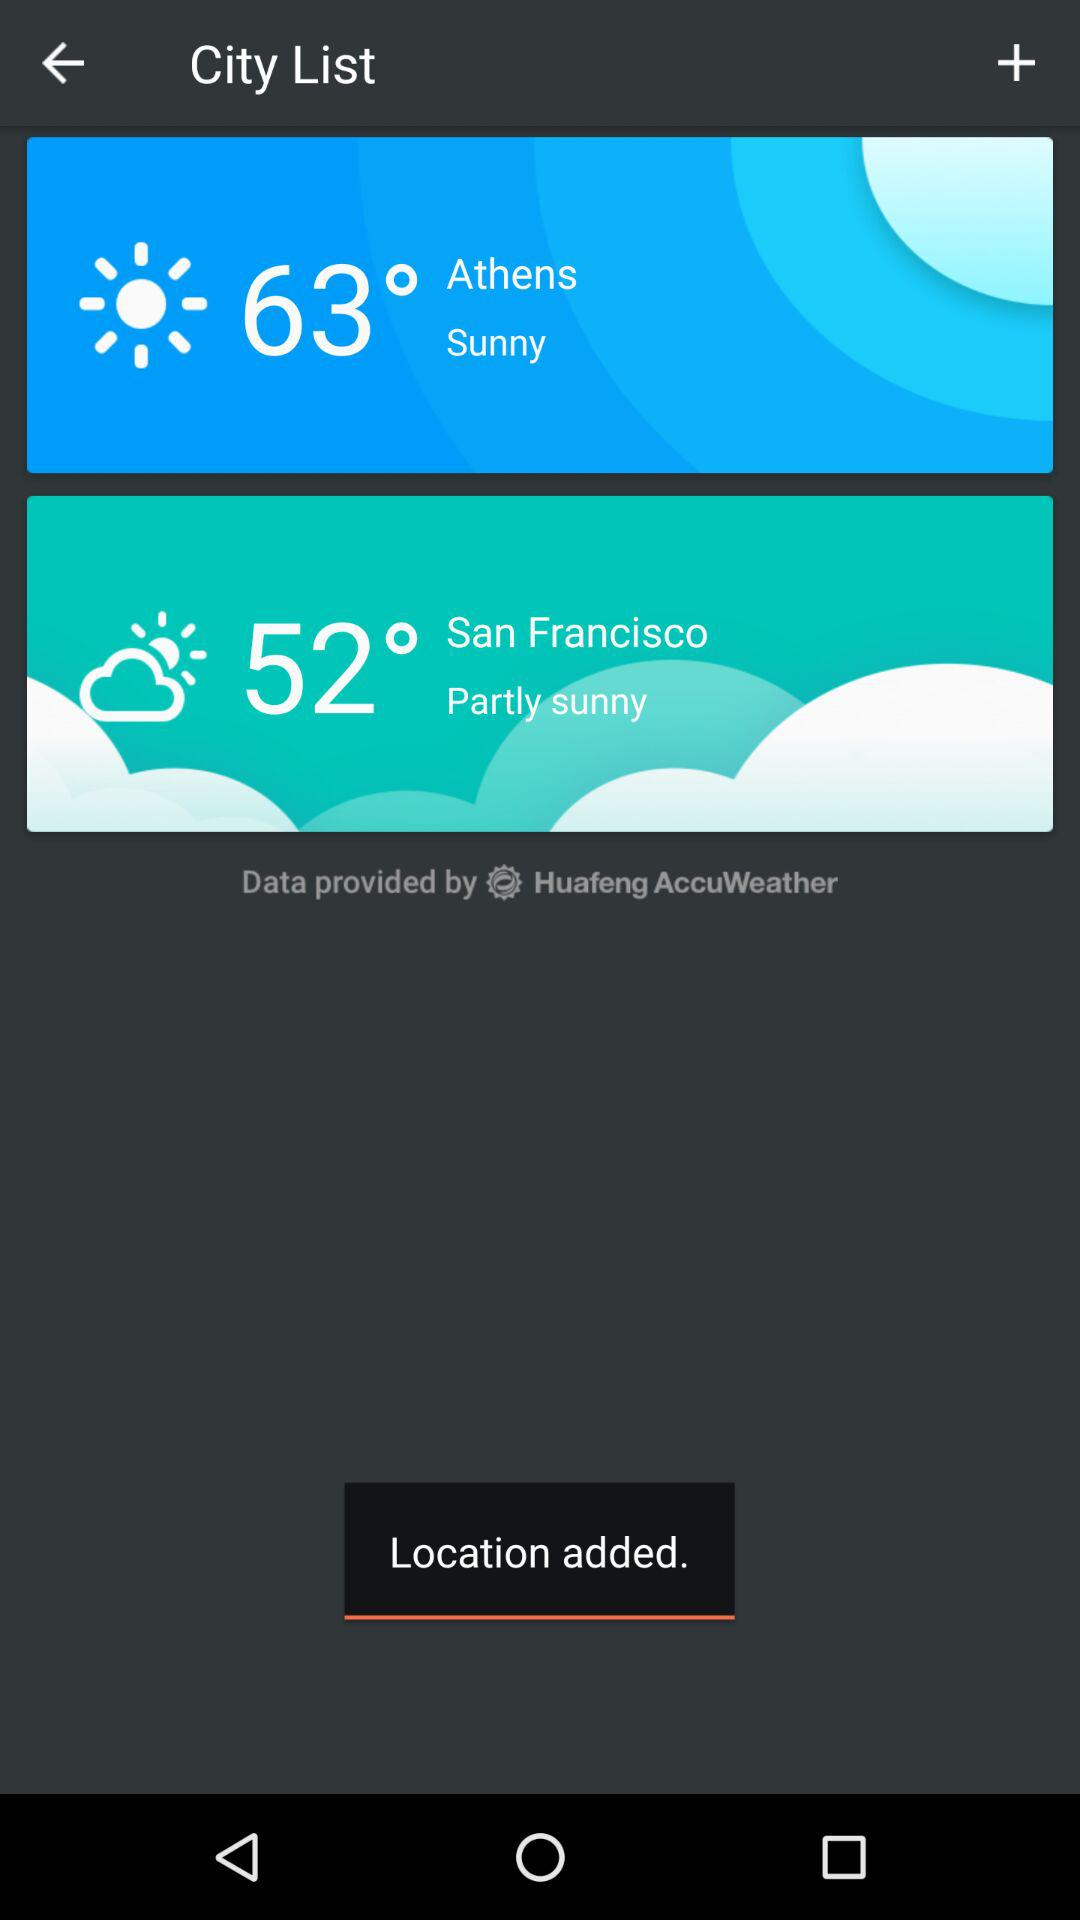How many degrees difference is there between the two temperatures?
Answer the question using a single word or phrase. 11 